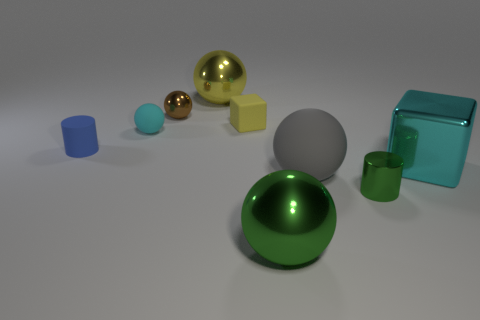Subtract all big yellow balls. How many balls are left? 4 Add 1 green shiny things. How many objects exist? 10 Subtract all yellow spheres. How many spheres are left? 4 Subtract all blocks. How many objects are left? 7 Subtract 2 blocks. How many blocks are left? 0 Subtract all green balls. Subtract all purple cylinders. How many balls are left? 4 Subtract all cyan spheres. How many brown cylinders are left? 0 Subtract all yellow shiny spheres. Subtract all big gray objects. How many objects are left? 7 Add 5 large green metal objects. How many large green metal objects are left? 6 Add 1 large purple objects. How many large purple objects exist? 1 